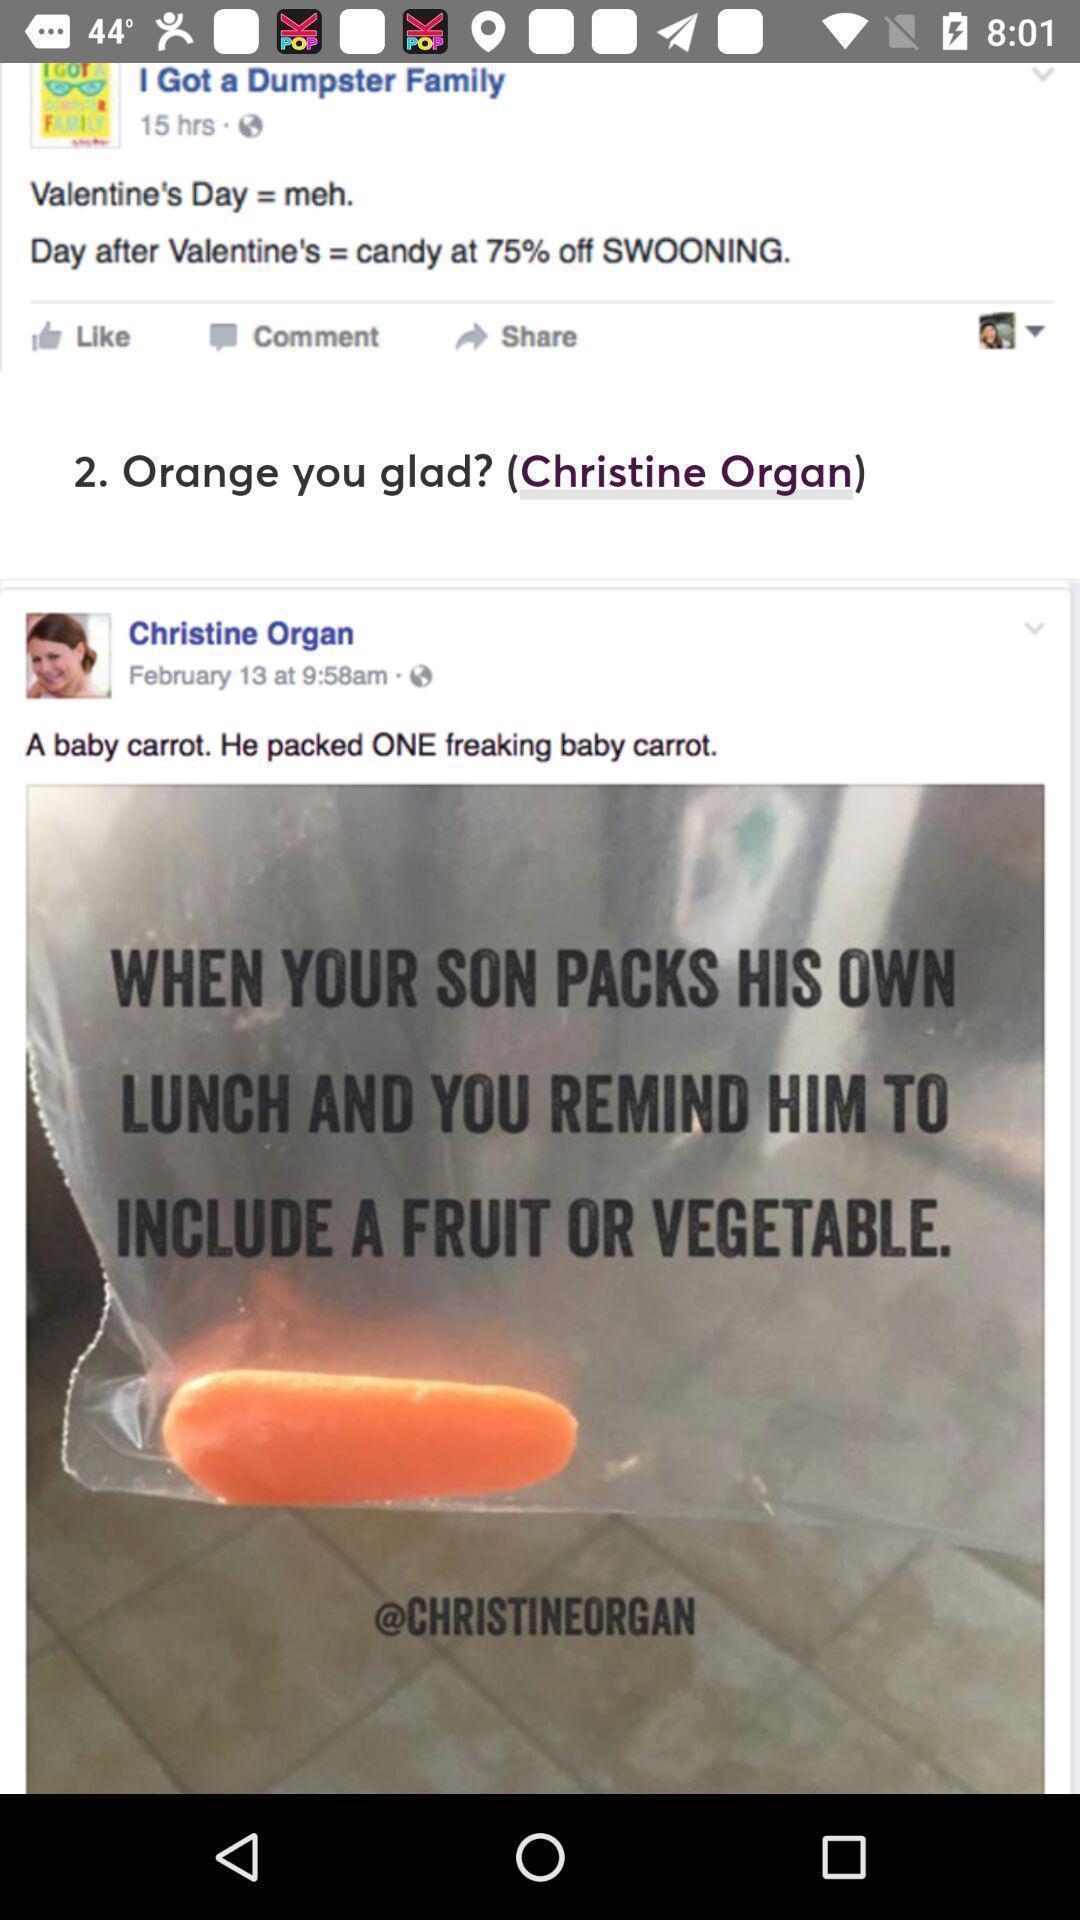Tell me what you see in this picture. Screen showing post. 